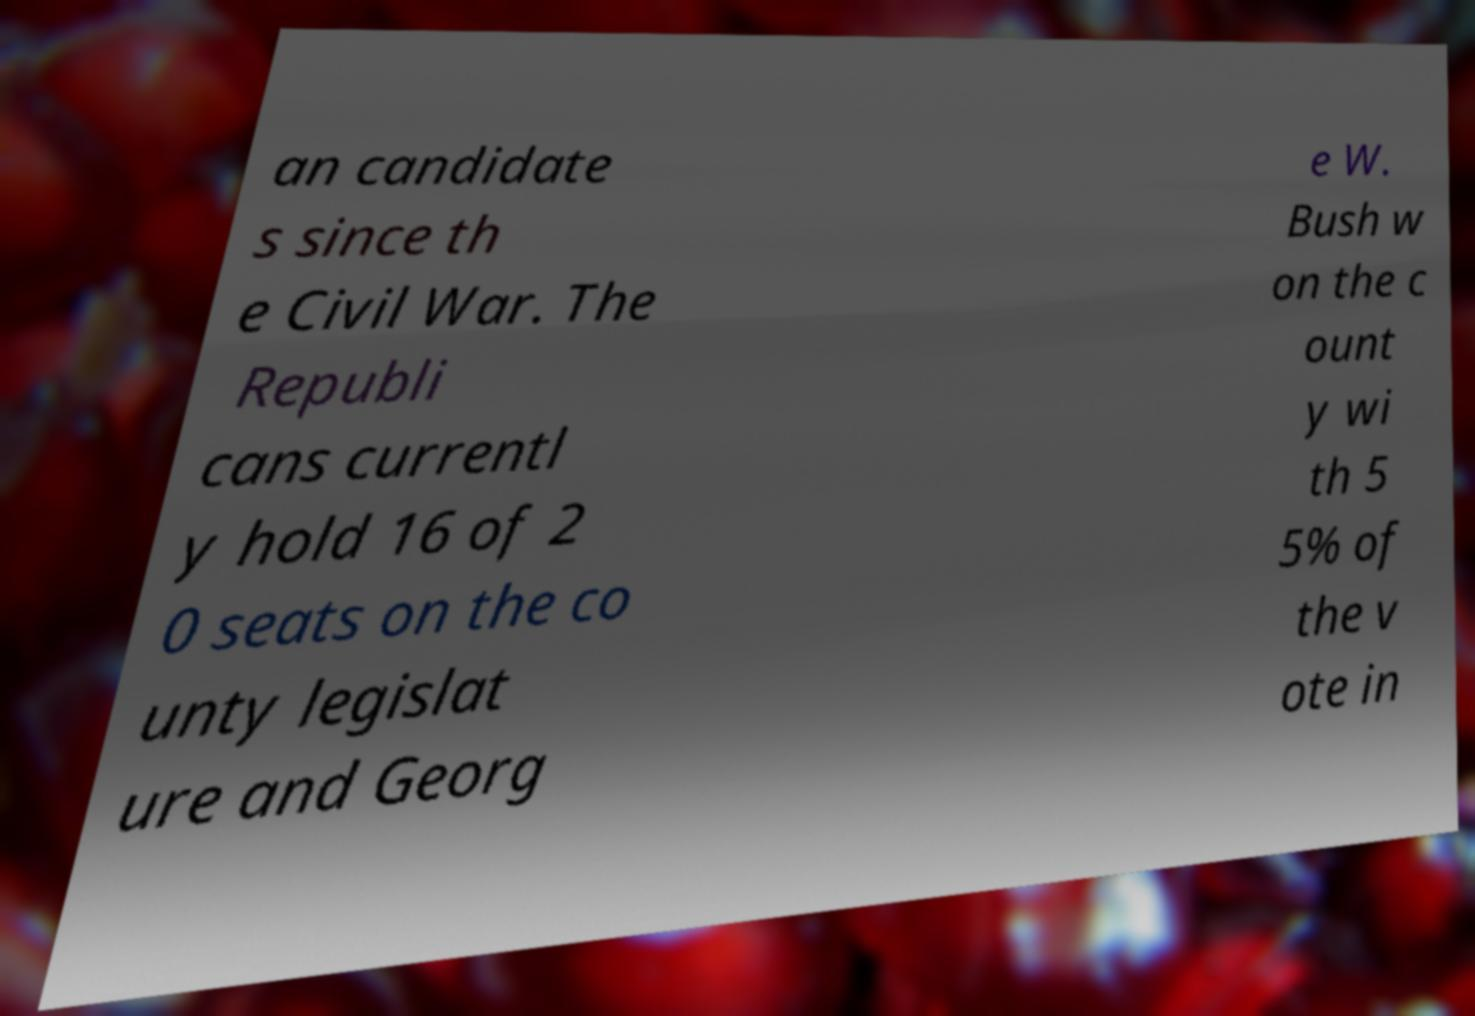Could you extract and type out the text from this image? an candidate s since th e Civil War. The Republi cans currentl y hold 16 of 2 0 seats on the co unty legislat ure and Georg e W. Bush w on the c ount y wi th 5 5% of the v ote in 